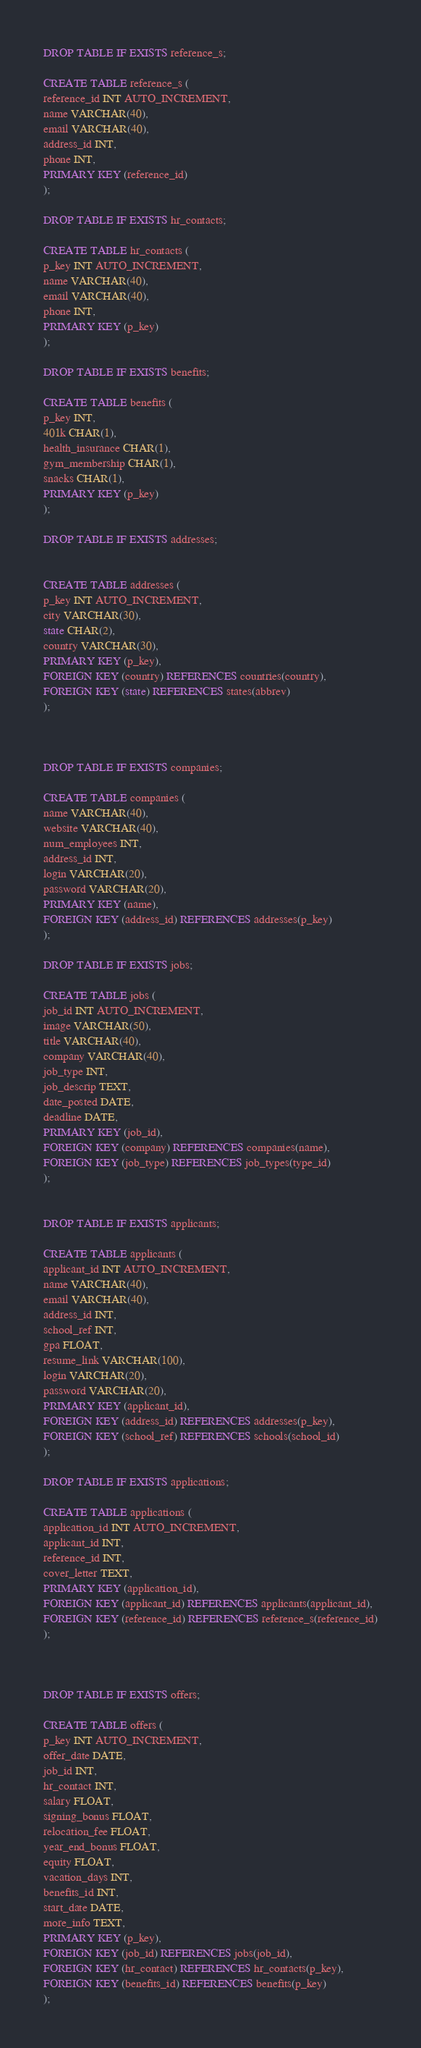Convert code to text. <code><loc_0><loc_0><loc_500><loc_500><_SQL_>

DROP TABLE IF EXISTS reference_s;

CREATE TABLE reference_s (
reference_id INT AUTO_INCREMENT,
name VARCHAR(40),
email VARCHAR(40),
address_id INT,
phone INT,
PRIMARY KEY (reference_id)
);

DROP TABLE IF EXISTS hr_contacts;

CREATE TABLE hr_contacts (
p_key INT AUTO_INCREMENT,
name VARCHAR(40),
email VARCHAR(40),
phone INT,
PRIMARY KEY (p_key)
);

DROP TABLE IF EXISTS benefits;

CREATE TABLE benefits (
p_key INT,
401k CHAR(1),
health_insurance CHAR(1),
gym_membership CHAR(1),
snacks CHAR(1),
PRIMARY KEY (p_key)
);

DROP TABLE IF EXISTS addresses;


CREATE TABLE addresses (
p_key INT AUTO_INCREMENT,
city VARCHAR(30),
state CHAR(2),
country VARCHAR(30),
PRIMARY KEY (p_key),
FOREIGN KEY (country) REFERENCES countries(country),
FOREIGN KEY (state) REFERENCES states(abbrev)
);



DROP TABLE IF EXISTS companies;

CREATE TABLE companies (
name VARCHAR(40),
website VARCHAR(40),
num_employees INT,
address_id INT,
login VARCHAR(20),
password VARCHAR(20),
PRIMARY KEY (name),
FOREIGN KEY (address_id) REFERENCES addresses(p_key)
);

DROP TABLE IF EXISTS jobs;

CREATE TABLE jobs (
job_id INT AUTO_INCREMENT,
image VARCHAR(50), 
title VARCHAR(40),
company VARCHAR(40),
job_type INT,
job_descrip TEXT,
date_posted DATE,
deadline DATE,
PRIMARY KEY (job_id),
FOREIGN KEY (company) REFERENCES companies(name),
FOREIGN KEY (job_type) REFERENCES job_types(type_id)
);


DROP TABLE IF EXISTS applicants;

CREATE TABLE applicants (
applicant_id INT AUTO_INCREMENT,
name VARCHAR(40),
email VARCHAR(40),
address_id INT,
school_ref INT,
gpa FLOAT,
resume_link VARCHAR(100),
login VARCHAR(20),
password VARCHAR(20),
PRIMARY KEY (applicant_id),
FOREIGN KEY (address_id) REFERENCES addresses(p_key),
FOREIGN KEY (school_ref) REFERENCES schools(school_id)
);

DROP TABLE IF EXISTS applications;

CREATE TABLE applications (
application_id INT AUTO_INCREMENT,
applicant_id INT,
reference_id INT,
cover_letter TEXT,
PRIMARY KEY (application_id),
FOREIGN KEY (applicant_id) REFERENCES applicants(applicant_id),
FOREIGN KEY (reference_id) REFERENCES reference_s(reference_id)
);



DROP TABLE IF EXISTS offers;

CREATE TABLE offers (
p_key INT AUTO_INCREMENT,
offer_date DATE,
job_id INT,
hr_contact INT,
salary FLOAT,
signing_bonus FLOAT,
relocation_fee FLOAT,
year_end_bonus FLOAT,
equity FLOAT,
vacation_days INT,
benefits_id INT,
start_date DATE,
more_info TEXT,
PRIMARY KEY (p_key),
FOREIGN KEY (job_id) REFERENCES jobs(job_id),
FOREIGN KEY (hr_contact) REFERENCES hr_contacts(p_key),
FOREIGN KEY (benefits_id) REFERENCES benefits(p_key)
);





</code> 